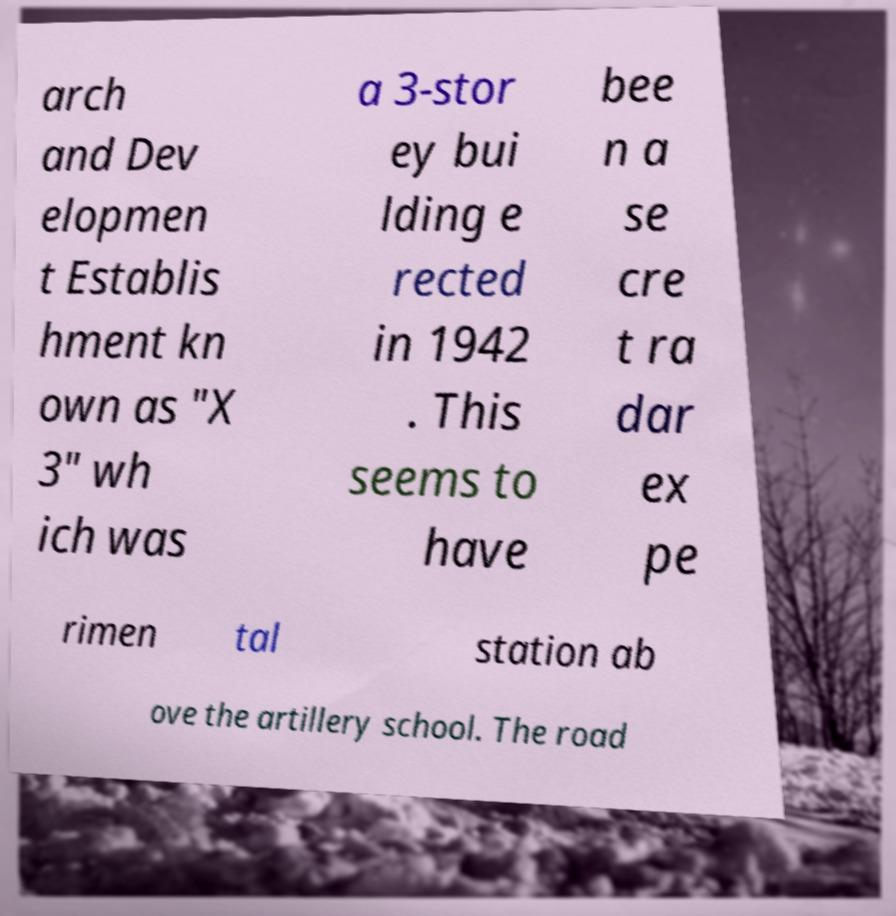I need the written content from this picture converted into text. Can you do that? arch and Dev elopmen t Establis hment kn own as "X 3" wh ich was a 3-stor ey bui lding e rected in 1942 . This seems to have bee n a se cre t ra dar ex pe rimen tal station ab ove the artillery school. The road 